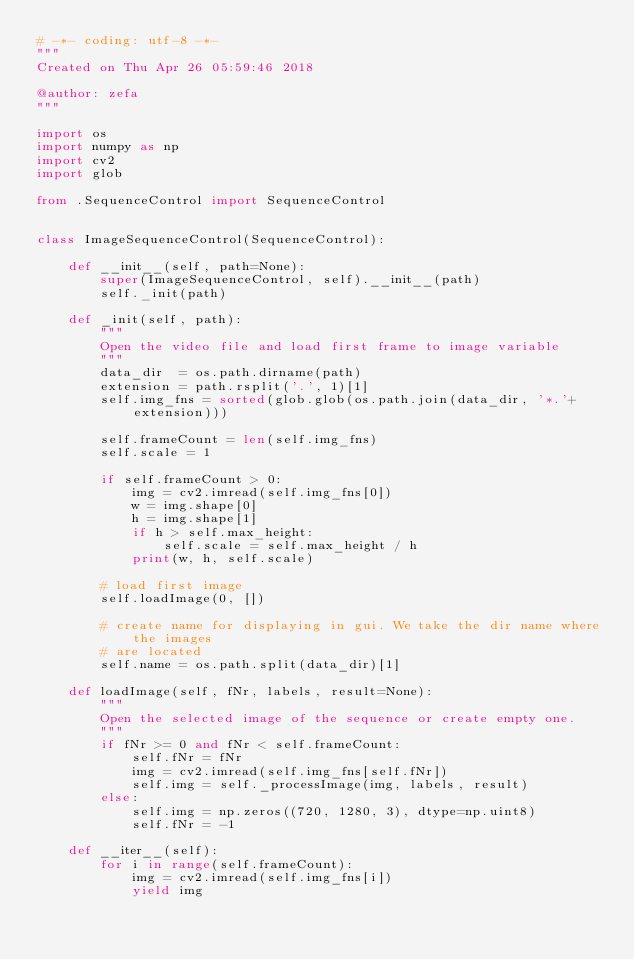<code> <loc_0><loc_0><loc_500><loc_500><_Python_># -*- coding: utf-8 -*-
"""
Created on Thu Apr 26 05:59:46 2018

@author: zefa
"""

import os
import numpy as np
import cv2
import glob

from .SequenceControl import SequenceControl


class ImageSequenceControl(SequenceControl):
    
    def __init__(self, path=None):
        super(ImageSequenceControl, self).__init__(path)
        self._init(path)
    
    def _init(self, path):
        """ 
        Open the video file and load first frame to image variable
        """
        data_dir  = os.path.dirname(path)
        extension = path.rsplit('.', 1)[1]
        self.img_fns = sorted(glob.glob(os.path.join(data_dir, '*.'+extension)))
        
        self.frameCount = len(self.img_fns)
        self.scale = 1
        
        if self.frameCount > 0:
            img = cv2.imread(self.img_fns[0])
            w = img.shape[0]
            h = img.shape[1]
            if h > self.max_height:
                self.scale = self.max_height / h
            print(w, h, self.scale)
            
        # load first image
        self.loadImage(0, [])

        # create name for displaying in gui. We take the dir name where the images
        # are located
        self.name = os.path.split(data_dir)[1]

    def loadImage(self, fNr, labels, result=None):
        """
        Open the selected image of the sequence or create empty one.
        """
        if fNr >= 0 and fNr < self.frameCount:
            self.fNr = fNr
            img = cv2.imread(self.img_fns[self.fNr])
            self.img = self._processImage(img, labels, result)
        else:
            self.img = np.zeros((720, 1280, 3), dtype=np.uint8)
            self.fNr = -1

    def __iter__(self):
        for i in range(self.frameCount):
            img = cv2.imread(self.img_fns[i])
            yield img

</code> 